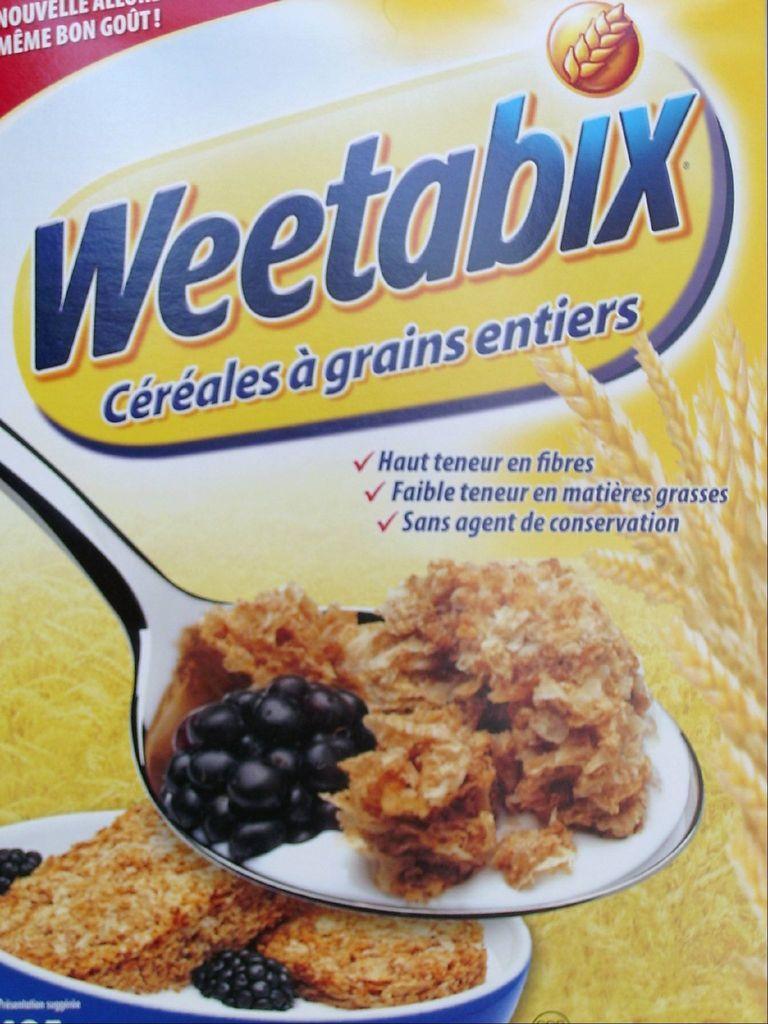Please provide a concise description of this image. In the image there is a poster. On the poster at the right side there is a spoon with cereals and mulberry fruit on it. At the bottom left of the image there is a bowl with cereals with mulberry fruits in it. And also on the poster there are grains image. And also on the poster there is something written on it. 